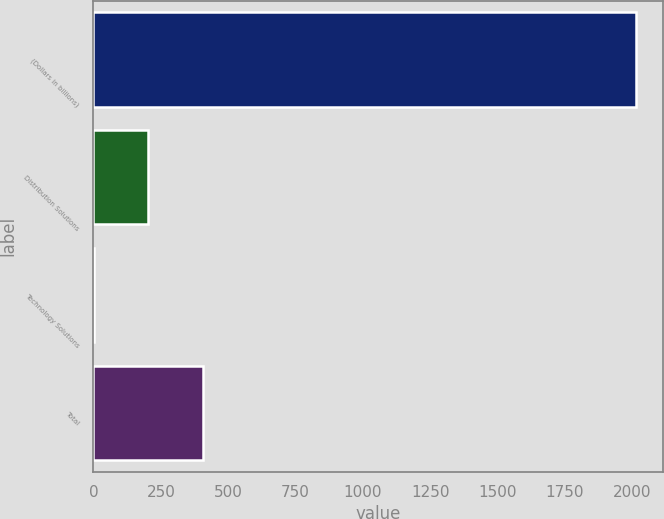Convert chart to OTSL. <chart><loc_0><loc_0><loc_500><loc_500><bar_chart><fcel>(Dollars in billions)<fcel>Distribution Solutions<fcel>Technology Solutions<fcel>Total<nl><fcel>2012<fcel>203.9<fcel>3<fcel>404.8<nl></chart> 